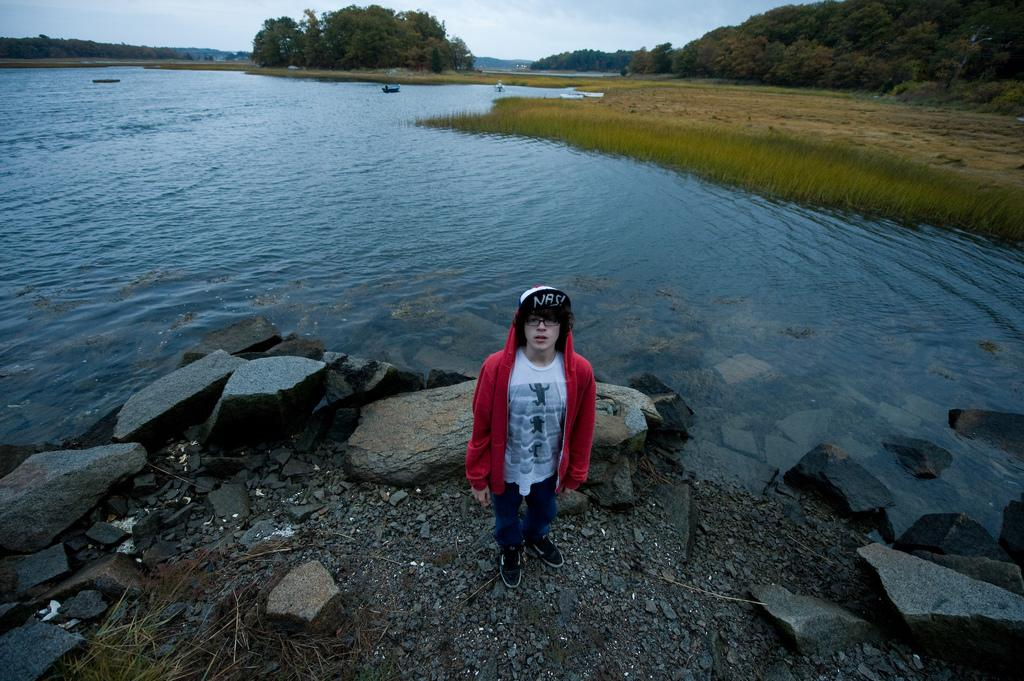What is the person in the image wearing? The person in the image is wearing a red jacket. What type of terrain can be seen in the image? There are stones, water, grass, trees, and mountains visible in the image. What is the color of the sky in the image? The sky is blue and white in color. What type of popcorn can be seen in the image? There is no popcorn present in the image. What time of day is it in the image? The time of day cannot be determined from the image alone, as there are no specific clues or indicators of morning or any other time of day. 